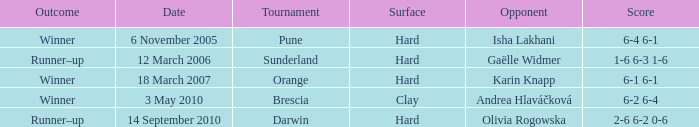What kind of surface was the tournament at Pune played on? Hard. 